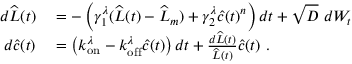<formula> <loc_0><loc_0><loc_500><loc_500>\begin{array} { r l } { d \widehat { L } ( t ) } & = - \left ( \gamma _ { 1 } ^ { \lambda } ( \widehat { L } ( t ) - \widehat { L } _ { m } ) + \gamma _ { 2 } ^ { \lambda } \widehat { c } ( t ) ^ { n } \right ) d t + \sqrt { D } \ d W _ { t } } \\ { d \widehat { c } ( t ) } & = \left ( k _ { o n } ^ { \lambda } - k _ { o f f } ^ { \lambda } \widehat { c } ( t ) \right ) d t + \frac { d \widehat { L } ( t ) } { \widehat { L } ( t ) } \widehat { c } ( t ) \ . } \end{array}</formula> 